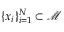<formula> <loc_0><loc_0><loc_500><loc_500>\{ x _ { i } \} _ { i = 1 } ^ { N } \subset \ m a t h s c r { M }</formula> 